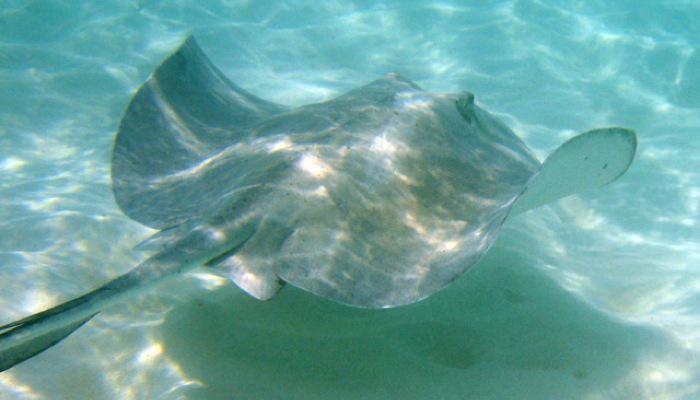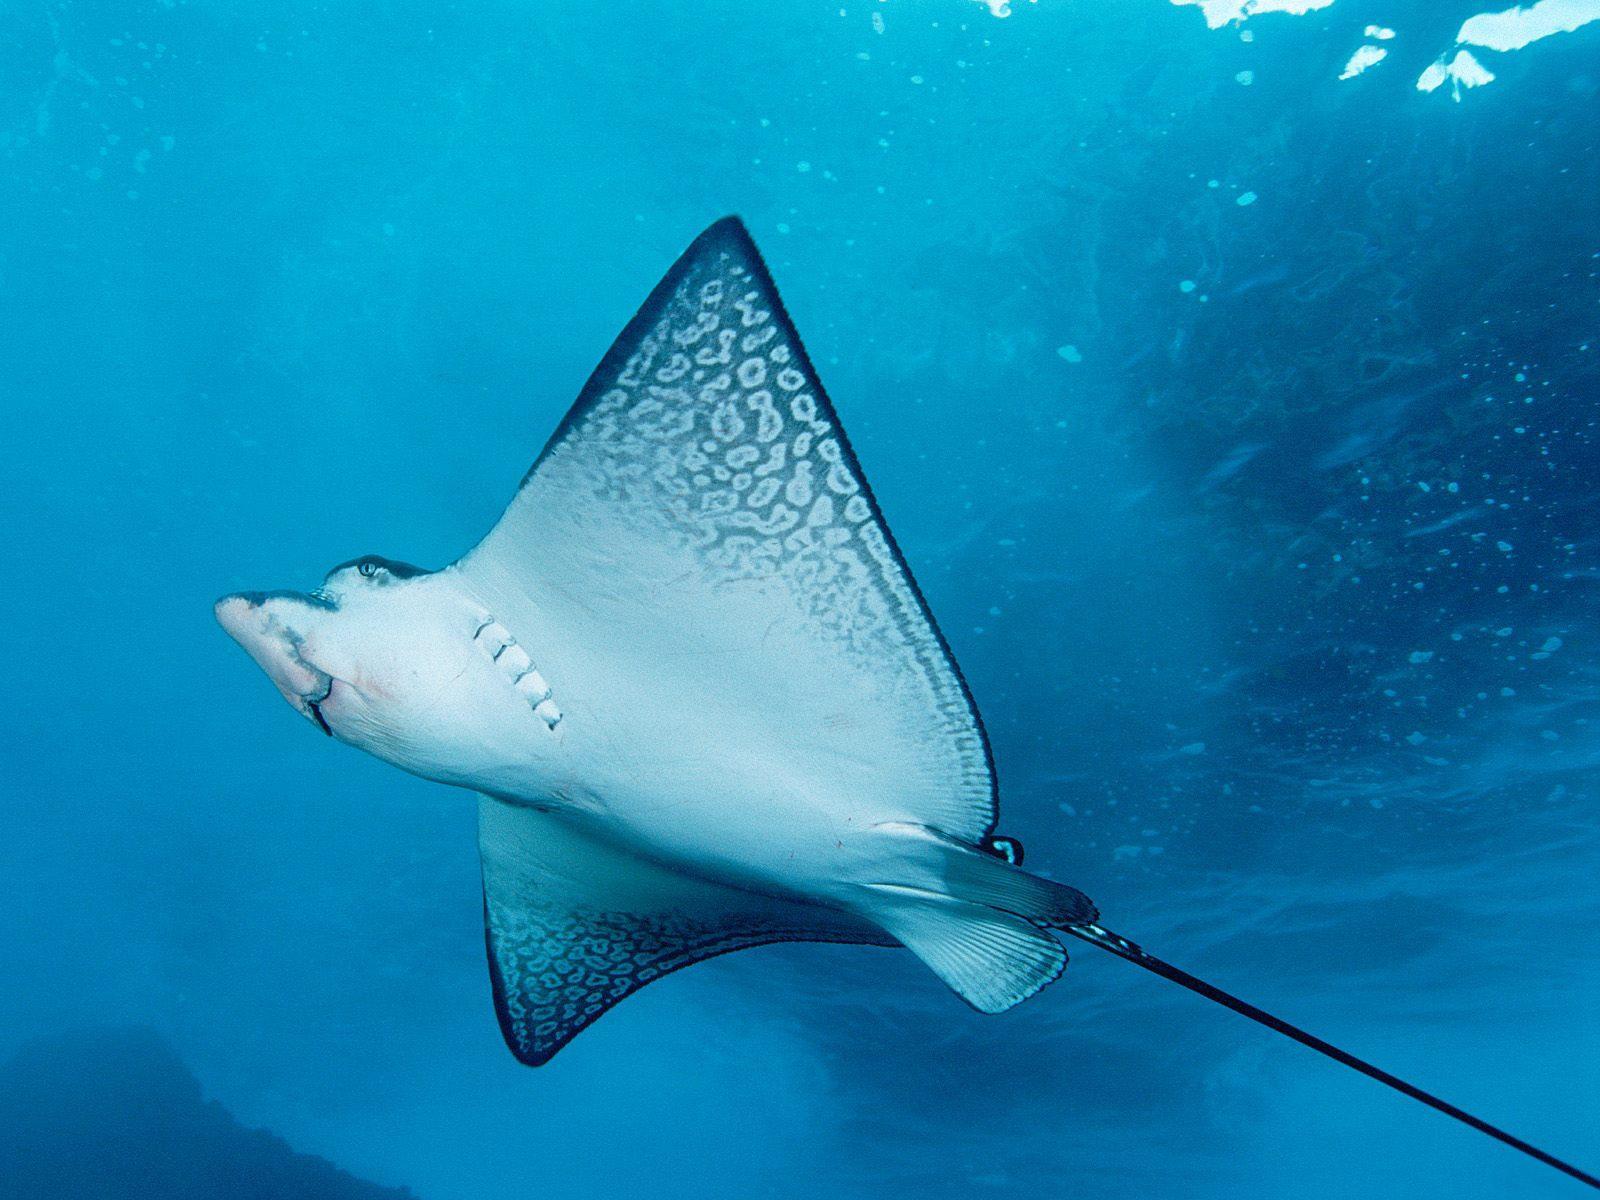The first image is the image on the left, the second image is the image on the right. For the images displayed, is the sentence "Right image shows the underbelly of a stingray, and the left shows a top-view of a stingray near the ocean bottom." factually correct? Answer yes or no. Yes. The first image is the image on the left, the second image is the image on the right. Examine the images to the left and right. Is the description "The top of the ray in the image on the left is visible." accurate? Answer yes or no. Yes. 